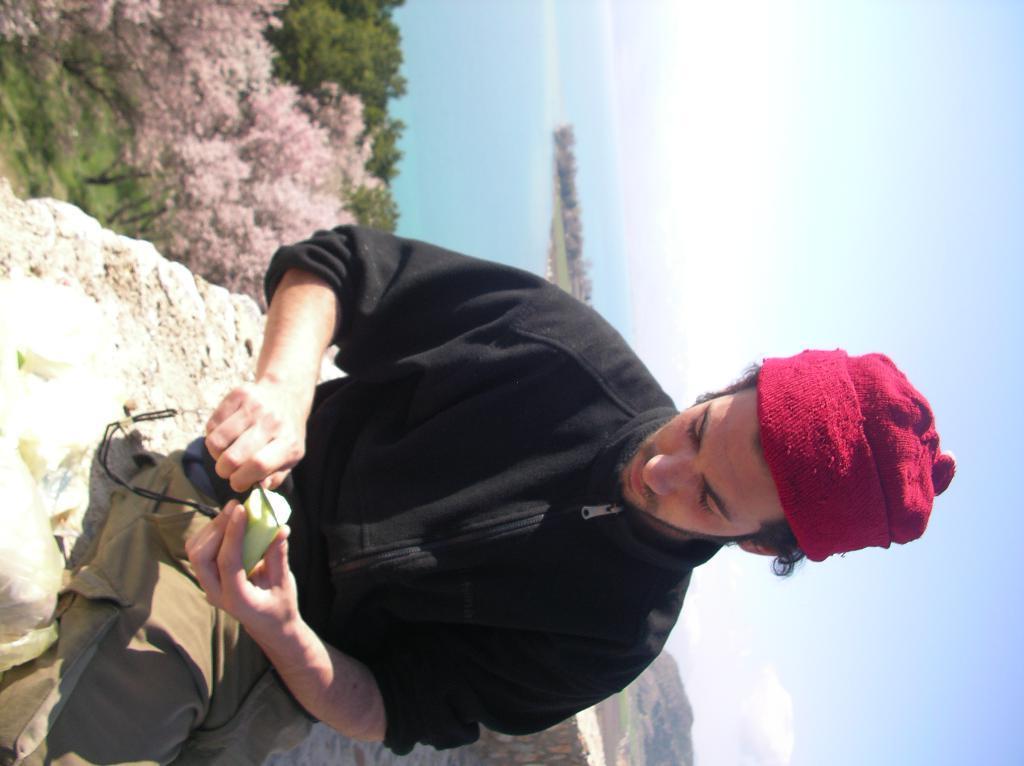Please provide a concise description of this image. In this picture we can see a man wearing a black jacket and sitting. He is cutting a cucumber. In the background we can see sky with clouds, hills and trees. 